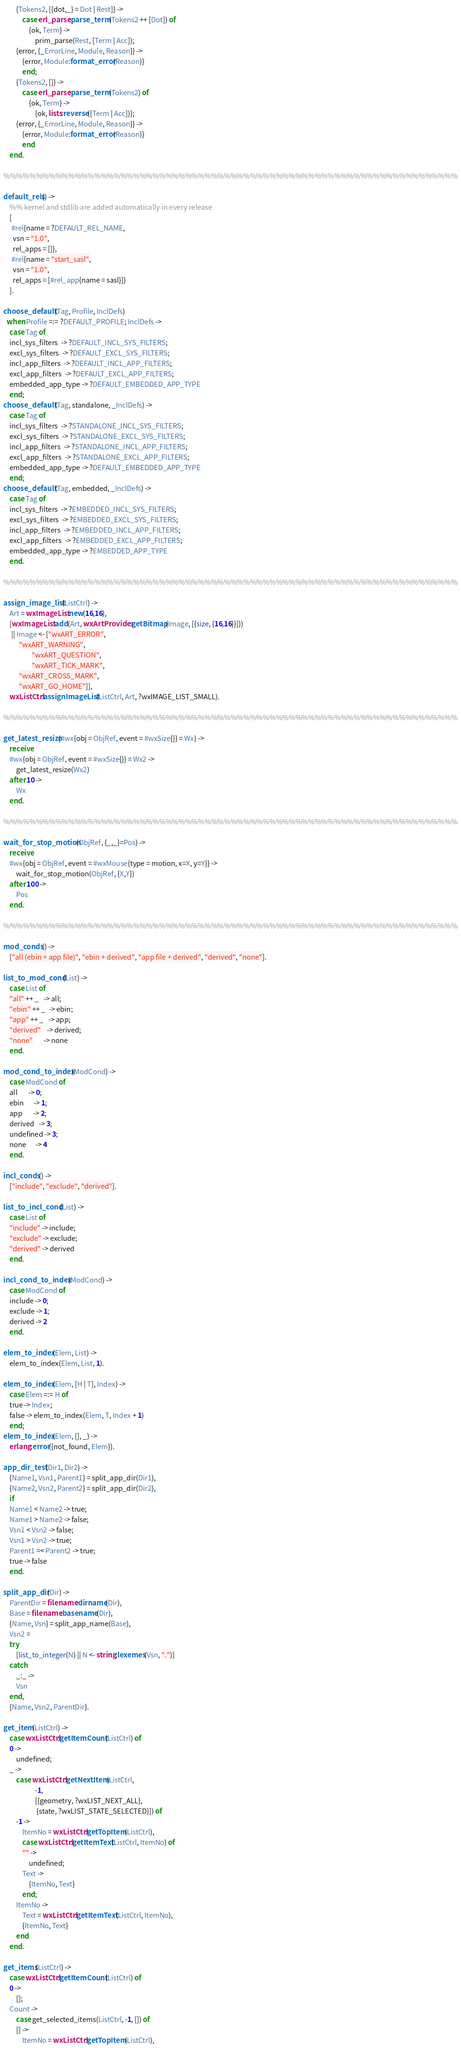Convert code to text. <code><loc_0><loc_0><loc_500><loc_500><_Erlang_>        {Tokens2, [{dot,_} = Dot | Rest]} ->
            case erl_parse:parse_term(Tokens2 ++ [Dot]) of
                {ok, Term} ->
                    prim_parse(Rest, [Term | Acc]);
		{error, {_ErrorLine, Module, Reason}} ->
		    {error, Module:format_error(Reason)}
            end;
        {Tokens2, []} ->
            case erl_parse:parse_term(Tokens2) of
                {ok, Term} ->
                    {ok, lists:reverse([Term | Acc])};
		{error, {_ErrorLine, Module, Reason}} ->
		    {error, Module:format_error(Reason)}
            end
    end.

%%%%%%%%%%%%%%%%%%%%%%%%%%%%%%%%%%%%%%%%%%%%%%%%%%%%%%%%%%%%%%%%%%%%%%

default_rels() ->
    %% kernel and stdlib are added automatically in every release
    [
     #rel{name = ?DEFAULT_REL_NAME,
	  vsn = "1.0",
	  rel_apps = []},
     #rel{name = "start_sasl",
	  vsn = "1.0",
	  rel_apps = [#rel_app{name = sasl}]}
    ].

choose_default(Tag, Profile, InclDefs)
  when Profile =:= ?DEFAULT_PROFILE; InclDefs ->
    case Tag of
	incl_sys_filters  -> ?DEFAULT_INCL_SYS_FILTERS;
	excl_sys_filters  -> ?DEFAULT_EXCL_SYS_FILTERS;
	incl_app_filters  -> ?DEFAULT_INCL_APP_FILTERS;
	excl_app_filters  -> ?DEFAULT_EXCL_APP_FILTERS;
	embedded_app_type -> ?DEFAULT_EMBEDDED_APP_TYPE
    end;
choose_default(Tag, standalone, _InclDefs) ->
    case Tag of
	incl_sys_filters  -> ?STANDALONE_INCL_SYS_FILTERS;
	excl_sys_filters  -> ?STANDALONE_EXCL_SYS_FILTERS;
	incl_app_filters  -> ?STANDALONE_INCL_APP_FILTERS;
	excl_app_filters  -> ?STANDALONE_EXCL_APP_FILTERS;
	embedded_app_type -> ?DEFAULT_EMBEDDED_APP_TYPE
    end;
choose_default(Tag, embedded, _InclDefs) ->
    case Tag of
	incl_sys_filters  -> ?EMBEDDED_INCL_SYS_FILTERS;
	excl_sys_filters  -> ?EMBEDDED_EXCL_SYS_FILTERS;
	incl_app_filters  -> ?EMBEDDED_INCL_APP_FILTERS;
	excl_app_filters  -> ?EMBEDDED_EXCL_APP_FILTERS;
	embedded_app_type -> ?EMBEDDED_APP_TYPE
    end.

%%%%%%%%%%%%%%%%%%%%%%%%%%%%%%%%%%%%%%%%%%%%%%%%%%%%%%%%%%%%%%%%%%%%%%

assign_image_list(ListCtrl) ->
    Art = wxImageList:new(16,16),
    [wxImageList:add(Art, wxArtProvider:getBitmap(Image, [{size, {16,16}}]))
     || Image <- ["wxART_ERROR",
		  "wxART_WARNING",
                  "wxART_QUESTION",
                  "wxART_TICK_MARK",
		  "wxART_CROSS_MARK",
		  "wxART_GO_HOME"]],
    wxListCtrl:assignImageList(ListCtrl, Art, ?wxIMAGE_LIST_SMALL).

%%%%%%%%%%%%%%%%%%%%%%%%%%%%%%%%%%%%%%%%%%%%%%%%%%%%%%%%%%%%%%%%%%%%%%

get_latest_resize(#wx{obj = ObjRef, event = #wxSize{}} = Wx) ->
    receive
	#wx{obj = ObjRef, event = #wxSize{}} = Wx2 ->
	    get_latest_resize(Wx2)
    after 10 ->
	    Wx
    end.

%%%%%%%%%%%%%%%%%%%%%%%%%%%%%%%%%%%%%%%%%%%%%%%%%%%%%%%%%%%%%%%%%%%%%%

wait_for_stop_motion(ObjRef, {_,_}=Pos) ->
    receive
	#wx{obj = ObjRef, event = #wxMouse{type = motion, x=X, y=Y}} ->
	    wait_for_stop_motion(ObjRef, {X,Y})
    after 100 ->
	    Pos
    end.

%%%%%%%%%%%%%%%%%%%%%%%%%%%%%%%%%%%%%%%%%%%%%%%%%%%%%%%%%%%%%%%%%%%%%%

mod_conds() ->
    ["all (ebin + app file)", "ebin + derived", "app file + derived", "derived", "none"].

list_to_mod_cond(List) ->
    case List of
	"all" ++ _   -> all;
 	"ebin" ++ _  -> ebin;
	"app" ++ _   -> app;
	"derived"    -> derived;
	"none"       -> none
    end.

mod_cond_to_index(ModCond) ->
    case ModCond of
	all       -> 0;
	ebin      -> 1;	
	app       -> 2;
	derived   -> 3;
	undefined -> 3;
	none      -> 4
    end.

incl_conds() ->
    ["include", "exclude", "derived"].

list_to_incl_cond(List) ->
    case List of
	"include" -> include;
 	"exclude" -> exclude;
	"derived" -> derived
    end.

incl_cond_to_index(ModCond) ->
    case ModCond of
	include -> 0;
	exclude -> 1;	
	derived -> 2
    end.

elem_to_index(Elem, List) ->
    elem_to_index(Elem, List, 1).

elem_to_index(Elem, [H | T], Index) ->
    case Elem =:= H of
	true -> Index;
	false -> elem_to_index(Elem, T, Index + 1)
    end;
elem_to_index(Elem, [], _) ->
    erlang:error({not_found, Elem}).

app_dir_test(Dir1, Dir2) ->
    {Name1, Vsn1, Parent1} = split_app_dir(Dir1),
    {Name2, Vsn2, Parent2} = split_app_dir(Dir2),
    if
	Name1 < Name2 -> true;
	Name1 > Name2 -> false;
	Vsn1 < Vsn2 -> false;
	Vsn1 > Vsn2 -> true;
	Parent1 =< Parent2 -> true;
	true -> false
    end.

split_app_dir(Dir) ->
    ParentDir = filename:dirname(Dir),
    Base = filename:basename(Dir),
    {Name, Vsn} = split_app_name(Base),
    Vsn2 =
	try
	    [list_to_integer(N) || N <- string:lexemes(Vsn, ".")]
	catch
	    _:_ ->
		Vsn
	end,
    {Name, Vsn2, ParentDir}.

get_item(ListCtrl) ->
    case wxListCtrl:getItemCount(ListCtrl) of
	0 ->
	    undefined;
	_ ->
	    case wxListCtrl:getNextItem(ListCtrl,
					-1,
					[{geometry, ?wxLIST_NEXT_ALL},
					 {state, ?wxLIST_STATE_SELECTED}]) of
		-1 ->
		    ItemNo = wxListCtrl:getTopItem(ListCtrl),
		    case wxListCtrl:getItemText(ListCtrl, ItemNo) of
			"" ->
			    undefined;
			Text ->
			    {ItemNo, Text}
		    end;
		ItemNo ->
		    Text = wxListCtrl:getItemText(ListCtrl, ItemNo),
		    {ItemNo, Text}
	    end
    end.

get_items(ListCtrl) ->
    case wxListCtrl:getItemCount(ListCtrl) of
	0 ->
	    [];
	Count ->
	    case get_selected_items(ListCtrl, -1, []) of
		[] ->
		    ItemNo = wxListCtrl:getTopItem(ListCtrl),</code> 